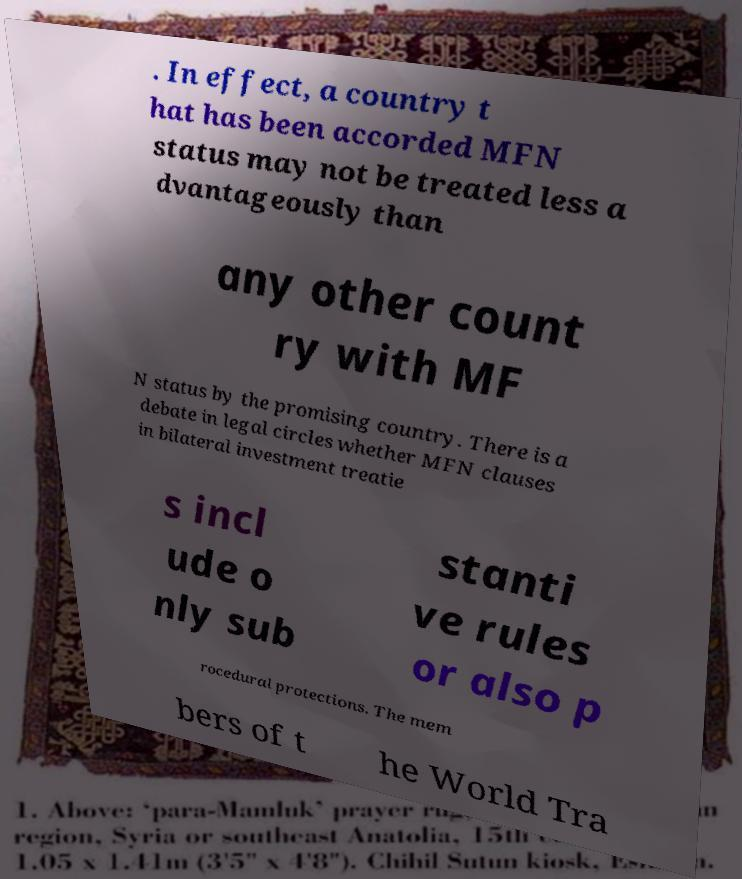Could you assist in decoding the text presented in this image and type it out clearly? . In effect, a country t hat has been accorded MFN status may not be treated less a dvantageously than any other count ry with MF N status by the promising country. There is a debate in legal circles whether MFN clauses in bilateral investment treatie s incl ude o nly sub stanti ve rules or also p rocedural protections. The mem bers of t he World Tra 